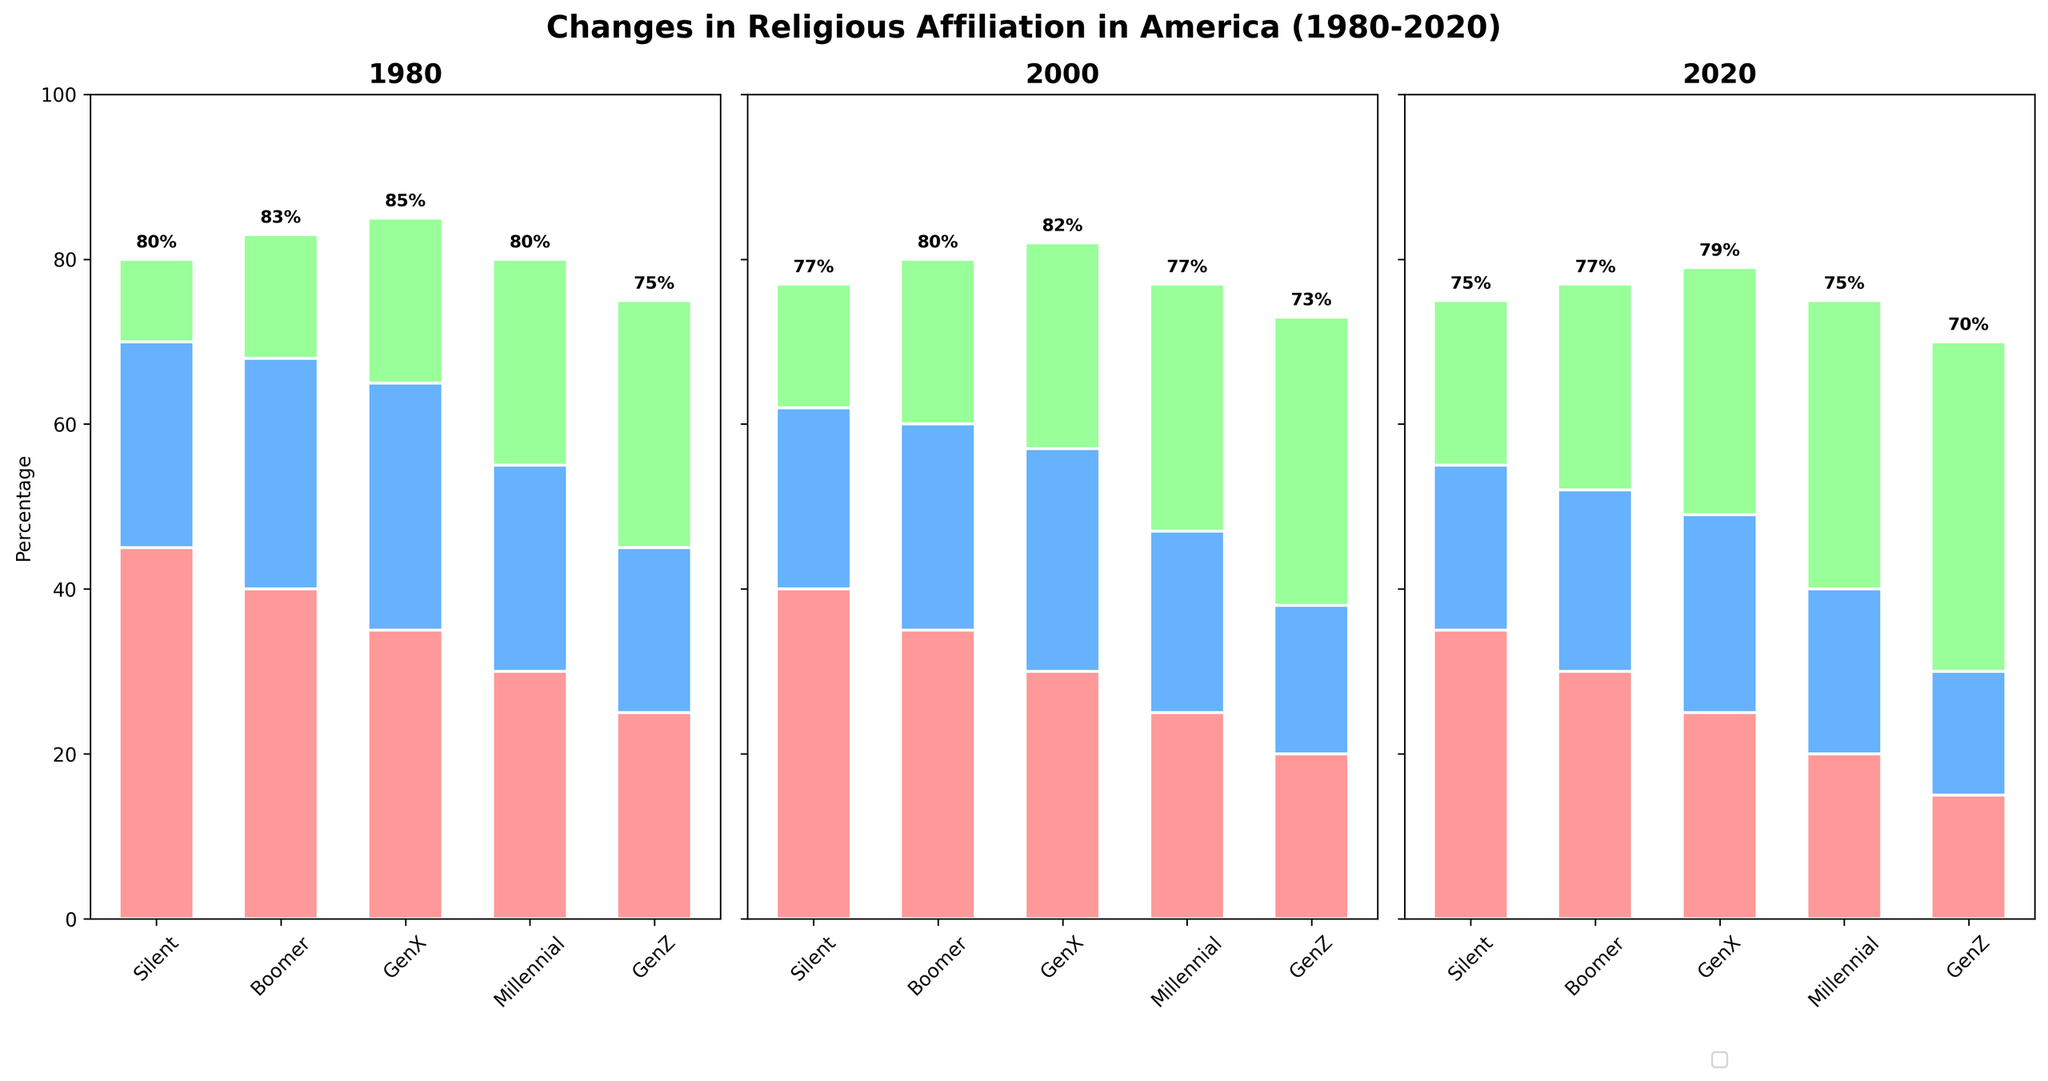What is the title of the plot? The title is located at the top of the figure, displaying the main subject. From the visual, it reads "Changes in Religious Affiliation in America (1980-2020)."
Answer: Changes in Religious Affiliation in America (1980-2020) Which denomination has the highest percentage among the Silent generation in 1980? Look at the section labeled "1980" for the Silent generation and identify the tallest segment representing the denominations. Protestant has the highest at 45%.
Answer: Protestant How does the percentage of Unaffiliated in Generation Z change from 1980 to 2020? Examine the changing height of the Unaffiliated bar in the Generation Z section across the three years. It increases from 30% in 1980 to 40% in 2020.
Answer: Increases by 10% Which generation has the lowest percentage of Catholic affiliation in 2020? In the chart segment for 2020, compare the heights of the Catholic denominations across all generations. Generation Z has the lowest at 15%.
Answer: Generation Z Compare the total percentage of Unaffiliated individuals between Millennials and Boomers in 2020. Find the heights of the Unaffiliated segments for Millennials and Boomers in 2020, which are 35% and 25%, respectively. Then, compare these values. Millennials have a higher total percentage.
Answer: Millennials What is the overall trend in Protestant affiliation from 1980 to 2020 across all generations? Look at the Protestant segments for each generation in the years 1980, 2000, and 2020. The overall trend shows a continuous decrease in percentage across all generations.
Answer: Decreasing How much has the percentage of Catholic affiliation decreased for GenX from 1980 to 2020? Check the heights of the Catholic segments for GenX in 1980 and 2020, which are 30% and 24%, respectively. The decrease is the difference: 30% - 24% = 6%.
Answer: Decreased by 6% Which year shows the highest percentage of Unaffiliated individuals for all generations combined? Compare the heights of the Unaffiliated segments across all generations for each year. The year 2020 shows the highest percentage for all generations combined.
Answer: 2020 Which generation had the smallest change in Protestant affiliation percentages between 1980 and 2020? Calculate the difference for each generation's Protestant affiliation percentages between 1980 and 2020. The Silent generation changed from 45% to 35%, which is a 10% change.
Answer: Silent generation 